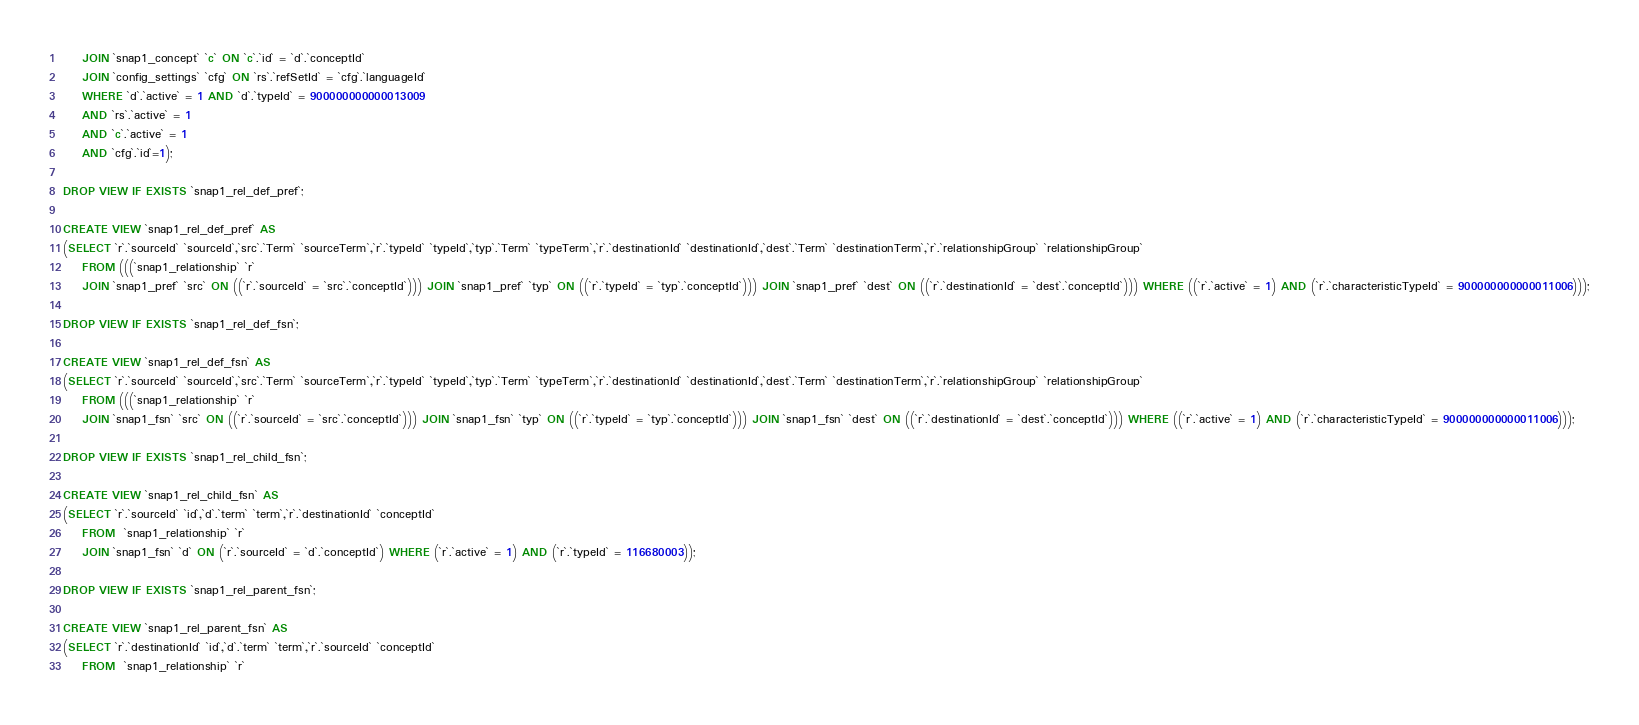Convert code to text. <code><loc_0><loc_0><loc_500><loc_500><_SQL_>	JOIN `snap1_concept` `c` ON `c`.`id` = `d`.`conceptId`
	JOIN `config_settings` `cfg` ON `rs`.`refSetId` = `cfg`.`languageId`
	WHERE `d`.`active` = 1 AND `d`.`typeId` = 900000000000013009
	AND `rs`.`active` = 1
	AND `c`.`active` = 1
	AND `cfg`.`id`=1);

DROP VIEW IF EXISTS `snap1_rel_def_pref`;

CREATE VIEW `snap1_rel_def_pref` AS
(SELECT `r`.`sourceId` `sourceId`,`src`.`Term` `sourceTerm`,`r`.`typeId` `typeId`,`typ`.`Term` `typeTerm`,`r`.`destinationId` `destinationId`,`dest`.`Term` `destinationTerm`,`r`.`relationshipGroup` `relationshipGroup`
	FROM (((`snap1_relationship` `r`
	JOIN `snap1_pref` `src` ON ((`r`.`sourceId` = `src`.`conceptId`))) JOIN `snap1_pref` `typ` ON ((`r`.`typeId` = `typ`.`conceptId`))) JOIN `snap1_pref` `dest` ON ((`r`.`destinationId` = `dest`.`conceptId`))) WHERE ((`r`.`active` = 1) AND (`r`.`characteristicTypeId` = 900000000000011006)));

DROP VIEW IF EXISTS `snap1_rel_def_fsn`;

CREATE VIEW `snap1_rel_def_fsn` AS
(SELECT `r`.`sourceId` `sourceId`,`src`.`Term` `sourceTerm`,`r`.`typeId` `typeId`,`typ`.`Term` `typeTerm`,`r`.`destinationId` `destinationId`,`dest`.`Term` `destinationTerm`,`r`.`relationshipGroup` `relationshipGroup`
	FROM (((`snap1_relationship` `r`
	JOIN `snap1_fsn` `src` ON ((`r`.`sourceId` = `src`.`conceptId`))) JOIN `snap1_fsn` `typ` ON ((`r`.`typeId` = `typ`.`conceptId`))) JOIN `snap1_fsn` `dest` ON ((`r`.`destinationId` = `dest`.`conceptId`))) WHERE ((`r`.`active` = 1) AND (`r`.`characteristicTypeId` = 900000000000011006)));

DROP VIEW IF EXISTS `snap1_rel_child_fsn`;

CREATE VIEW `snap1_rel_child_fsn` AS
(SELECT `r`.`sourceId` `id`,`d`.`term` `term`,`r`.`destinationId` `conceptId`
	FROM  `snap1_relationship` `r`
	JOIN `snap1_fsn` `d` ON (`r`.`sourceId` = `d`.`conceptId`) WHERE (`r`.`active` = 1) AND (`r`.`typeId` = 116680003));

DROP VIEW IF EXISTS `snap1_rel_parent_fsn`;

CREATE VIEW `snap1_rel_parent_fsn` AS
(SELECT `r`.`destinationId` `id`,`d`.`term` `term`,`r`.`sourceId` `conceptId`
	FROM  `snap1_relationship` `r`</code> 